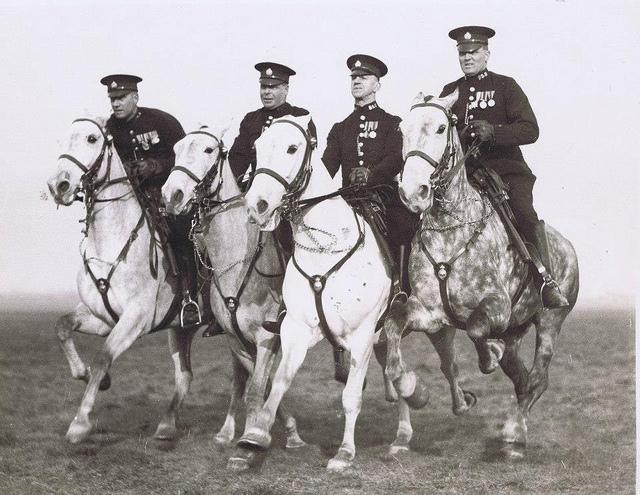How many men are in the pic?
Give a very brief answer. 4. Which horse could be "dapple-gray"?
Quick response, please. Far right. Who are riding the horses?
Answer briefly. Soldiers. Are these war horses?
Write a very short answer. Yes. 